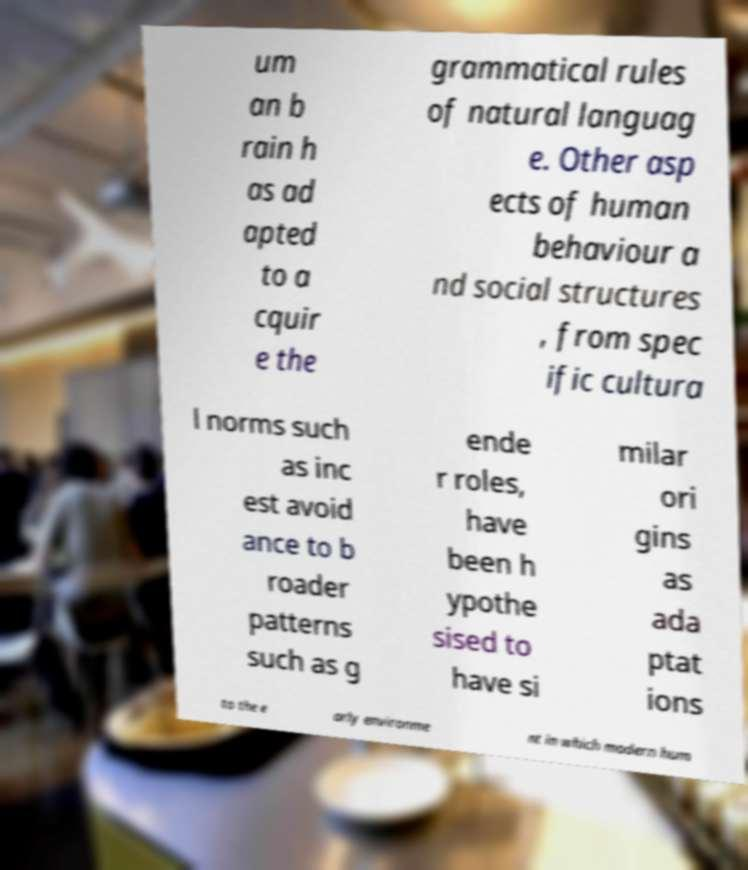For documentation purposes, I need the text within this image transcribed. Could you provide that? um an b rain h as ad apted to a cquir e the grammatical rules of natural languag e. Other asp ects of human behaviour a nd social structures , from spec ific cultura l norms such as inc est avoid ance to b roader patterns such as g ende r roles, have been h ypothe sised to have si milar ori gins as ada ptat ions to the e arly environme nt in which modern hum 